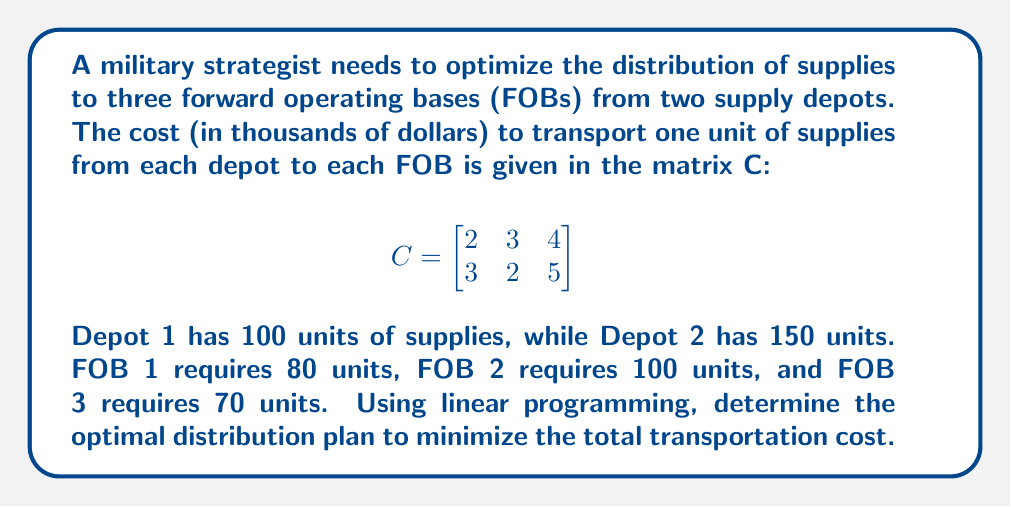Can you answer this question? Let's solve this problem using the following steps:

1) Define variables:
   Let $x_{ij}$ be the number of units transported from Depot i to FOB j.

2) Set up the objective function:
   Minimize Z = $2x_{11} + 3x_{12} + 4x_{13} + 3x_{21} + 2x_{22} + 5x_{23}$

3) Define constraints:
   Supply constraints:
   $x_{11} + x_{12} + x_{13} \leq 100$ (Depot 1)
   $x_{21} + x_{22} + x_{23} \leq 150$ (Depot 2)
   
   Demand constraints:
   $x_{11} + x_{21} = 80$ (FOB 1)
   $x_{12} + x_{22} = 100$ (FOB 2)
   $x_{13} + x_{23} = 70$ (FOB 3)

   Non-negativity constraints:
   $x_{ij} \geq 0$ for all i and j

4) Solve using the simplex method or linear programming software.

5) The optimal solution is:
   $x_{11} = 80$, $x_{12} = 20$, $x_{13} = 0$
   $x_{21} = 0$, $x_{22} = 80$, $x_{23} = 70$

6) Calculate the minimum cost:
   Z = $2(80) + 3(20) + 4(0) + 3(0) + 2(80) + 5(70)$
     = $160 + 60 + 160 + 350$
     = $730$

Therefore, the minimum total transportation cost is $730,000.
Answer: $730,000 